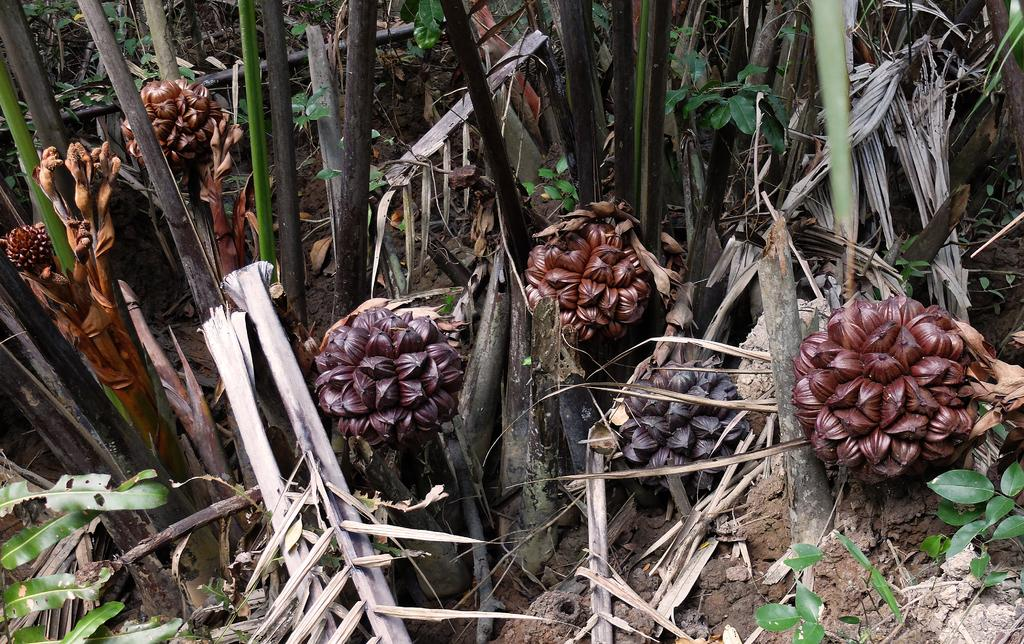What type of natural elements can be seen in the image? There are trees in the image. Where are the trees located? The trees are on the ground. What type of design can be seen on the quill in the image? There is no quill present in the image; it only features trees on the ground. 